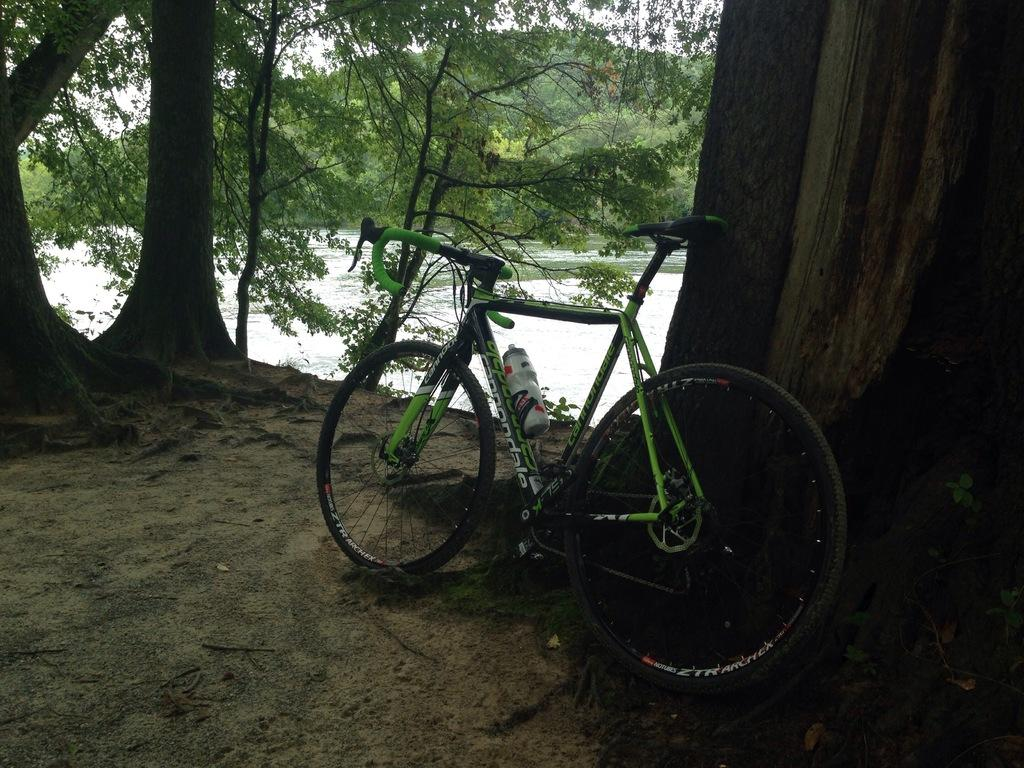What is the main object in the image? There is a bicycle in the image. Is there anything attached to the bicycle? Yes, there is a water bottle attached to the bicycle. What can be seen in the background of the image? There is a river, trees, and the sky visible in the background of the image. What type of tooth is visible in the image? There is no tooth present in the image. Can you tell me how many laborers are working near the river in the image? There is no laborer present in the image; it only features a bicycle and a water bottle. 